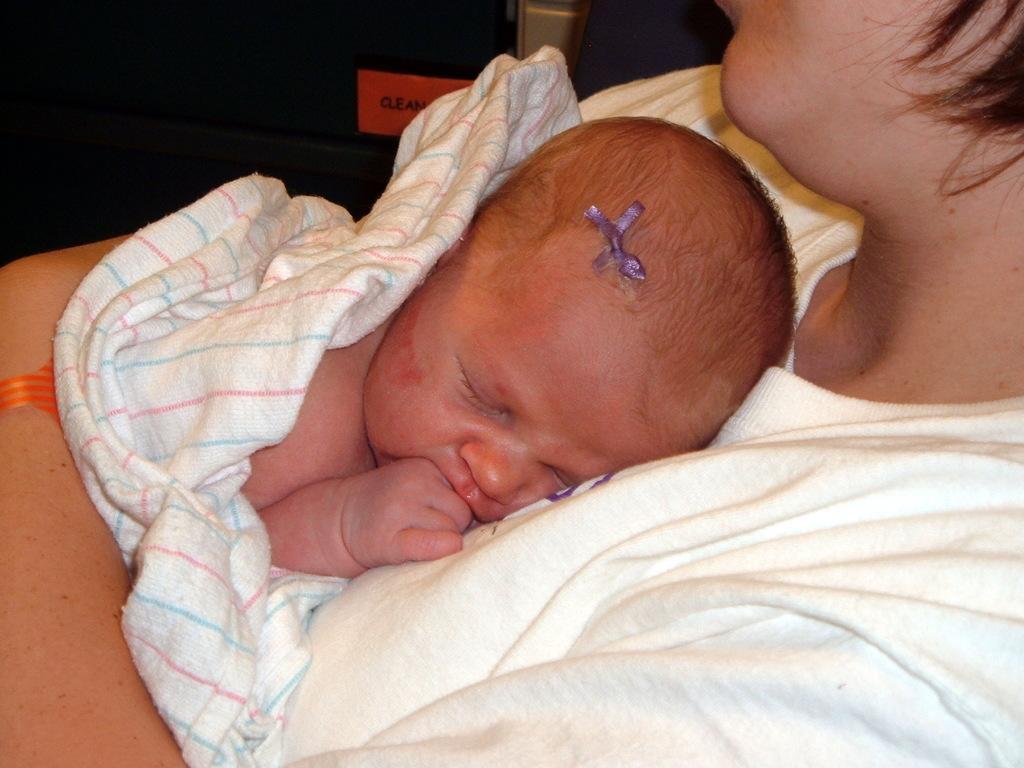Describe this image in one or two sentences. In this image there is a person truncated towards the right of the image, there is a baby sleeping, at the background of the image there is an object truncated. 